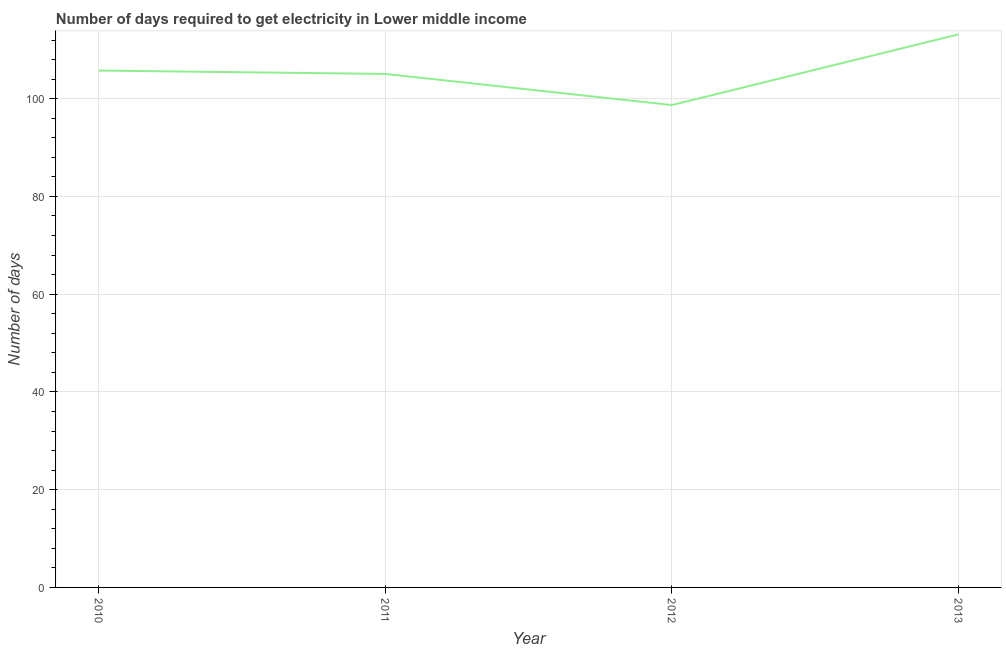What is the time to get electricity in 2011?
Offer a very short reply. 105.07. Across all years, what is the maximum time to get electricity?
Make the answer very short. 113.16. Across all years, what is the minimum time to get electricity?
Offer a very short reply. 98.7. In which year was the time to get electricity maximum?
Provide a succinct answer. 2013. In which year was the time to get electricity minimum?
Offer a terse response. 2012. What is the sum of the time to get electricity?
Provide a short and direct response. 422.68. What is the difference between the time to get electricity in 2012 and 2013?
Give a very brief answer. -14.47. What is the average time to get electricity per year?
Give a very brief answer. 105.67. What is the median time to get electricity?
Offer a terse response. 105.41. What is the ratio of the time to get electricity in 2011 to that in 2013?
Provide a short and direct response. 0.93. What is the difference between the highest and the second highest time to get electricity?
Offer a very short reply. 7.41. What is the difference between the highest and the lowest time to get electricity?
Offer a very short reply. 14.47. In how many years, is the time to get electricity greater than the average time to get electricity taken over all years?
Offer a terse response. 2. How many lines are there?
Your answer should be compact. 1. What is the difference between two consecutive major ticks on the Y-axis?
Offer a very short reply. 20. Does the graph contain any zero values?
Keep it short and to the point. No. What is the title of the graph?
Provide a succinct answer. Number of days required to get electricity in Lower middle income. What is the label or title of the X-axis?
Provide a short and direct response. Year. What is the label or title of the Y-axis?
Ensure brevity in your answer.  Number of days. What is the Number of days in 2010?
Provide a short and direct response. 105.76. What is the Number of days of 2011?
Your answer should be compact. 105.07. What is the Number of days of 2012?
Provide a succinct answer. 98.7. What is the Number of days in 2013?
Make the answer very short. 113.16. What is the difference between the Number of days in 2010 and 2011?
Your answer should be compact. 0.69. What is the difference between the Number of days in 2010 and 2012?
Ensure brevity in your answer.  7.06. What is the difference between the Number of days in 2010 and 2013?
Ensure brevity in your answer.  -7.41. What is the difference between the Number of days in 2011 and 2012?
Offer a very short reply. 6.37. What is the difference between the Number of days in 2011 and 2013?
Your answer should be very brief. -8.1. What is the difference between the Number of days in 2012 and 2013?
Your response must be concise. -14.47. What is the ratio of the Number of days in 2010 to that in 2012?
Your answer should be very brief. 1.07. What is the ratio of the Number of days in 2010 to that in 2013?
Offer a terse response. 0.94. What is the ratio of the Number of days in 2011 to that in 2012?
Keep it short and to the point. 1.06. What is the ratio of the Number of days in 2011 to that in 2013?
Offer a very short reply. 0.93. What is the ratio of the Number of days in 2012 to that in 2013?
Your answer should be very brief. 0.87. 